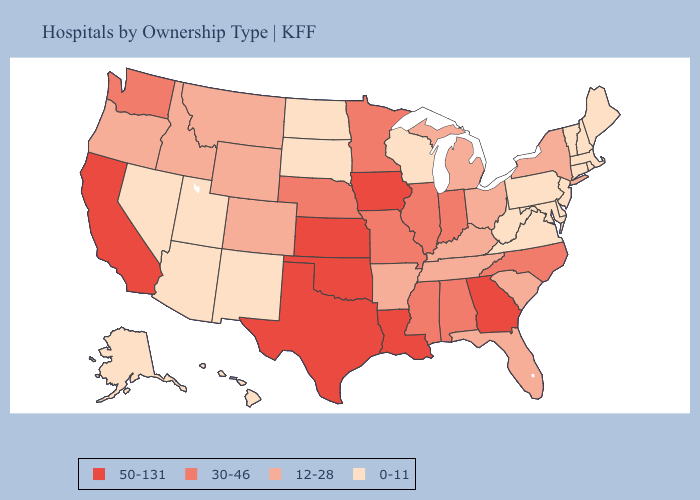What is the lowest value in states that border Louisiana?
Short answer required. 12-28. What is the value of Tennessee?
Answer briefly. 12-28. Does Michigan have the highest value in the MidWest?
Keep it brief. No. Name the states that have a value in the range 50-131?
Quick response, please. California, Georgia, Iowa, Kansas, Louisiana, Oklahoma, Texas. What is the lowest value in the USA?
Be succinct. 0-11. Name the states that have a value in the range 30-46?
Short answer required. Alabama, Illinois, Indiana, Minnesota, Mississippi, Missouri, Nebraska, North Carolina, Washington. What is the value of Nevada?
Keep it brief. 0-11. Name the states that have a value in the range 12-28?
Be succinct. Arkansas, Colorado, Florida, Idaho, Kentucky, Michigan, Montana, New York, Ohio, Oregon, South Carolina, Tennessee, Wyoming. Name the states that have a value in the range 30-46?
Be succinct. Alabama, Illinois, Indiana, Minnesota, Mississippi, Missouri, Nebraska, North Carolina, Washington. Among the states that border Michigan , which have the lowest value?
Concise answer only. Wisconsin. Which states have the lowest value in the West?
Write a very short answer. Alaska, Arizona, Hawaii, Nevada, New Mexico, Utah. Does Kansas have the highest value in the USA?
Be succinct. Yes. What is the value of Utah?
Be succinct. 0-11. Does the first symbol in the legend represent the smallest category?
Short answer required. No. 